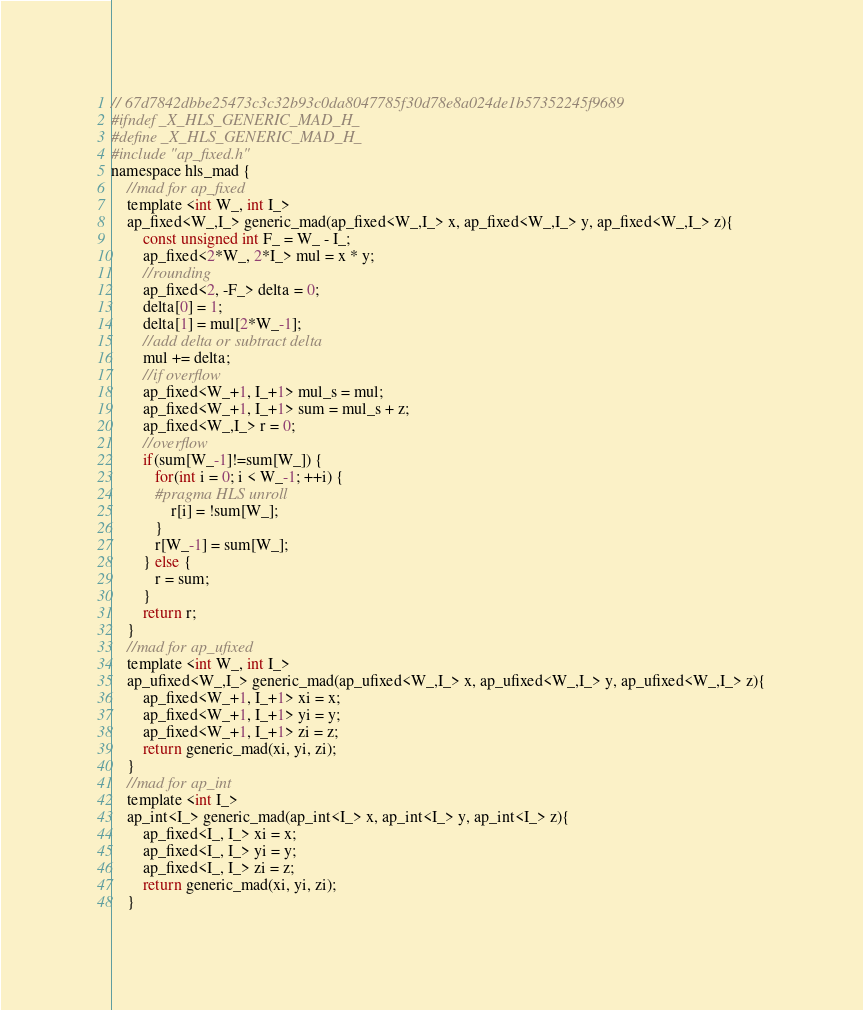<code> <loc_0><loc_0><loc_500><loc_500><_C_>// 67d7842dbbe25473c3c32b93c0da8047785f30d78e8a024de1b57352245f9689
#ifndef _X_HLS_GENERIC_MAD_H_
#define _X_HLS_GENERIC_MAD_H_
#include "ap_fixed.h"
namespace hls_mad {
    //mad for ap_fixed
    template <int W_, int I_>
    ap_fixed<W_,I_> generic_mad(ap_fixed<W_,I_> x, ap_fixed<W_,I_> y, ap_fixed<W_,I_> z){
        const unsigned int F_ = W_ - I_;
        ap_fixed<2*W_, 2*I_> mul = x * y;
        //rounding
        ap_fixed<2, -F_> delta = 0;
        delta[0] = 1;
        delta[1] = mul[2*W_-1];
        //add delta or subtract delta
        mul += delta;
        //if overflow
        ap_fixed<W_+1, I_+1> mul_s = mul;
        ap_fixed<W_+1, I_+1> sum = mul_s + z;
        ap_fixed<W_,I_> r = 0;
        //overflow
        if(sum[W_-1]!=sum[W_]) {
           for(int i = 0; i < W_-1; ++i) {
           #pragma HLS unroll
               r[i] = !sum[W_];
           }
           r[W_-1] = sum[W_];
        } else {
           r = sum;
        }
        return r;
    }
    //mad for ap_ufixed
    template <int W_, int I_>
    ap_ufixed<W_,I_> generic_mad(ap_ufixed<W_,I_> x, ap_ufixed<W_,I_> y, ap_ufixed<W_,I_> z){
        ap_fixed<W_+1, I_+1> xi = x;
        ap_fixed<W_+1, I_+1> yi = y;
        ap_fixed<W_+1, I_+1> zi = z;
        return generic_mad(xi, yi, zi);
    }
    //mad for ap_int
    template <int I_>
    ap_int<I_> generic_mad(ap_int<I_> x, ap_int<I_> y, ap_int<I_> z){
        ap_fixed<I_, I_> xi = x;
        ap_fixed<I_, I_> yi = y;
        ap_fixed<I_, I_> zi = z;
        return generic_mad(xi, yi, zi);
    }</code> 